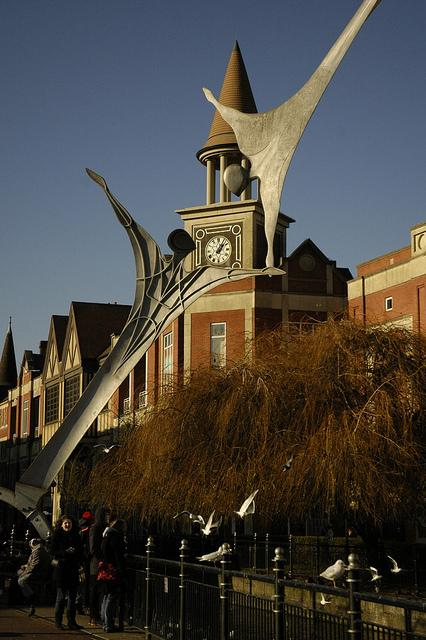The human-shaped decorations are made of what material? Please explain your reasoning. metal. The decorations are metal. 